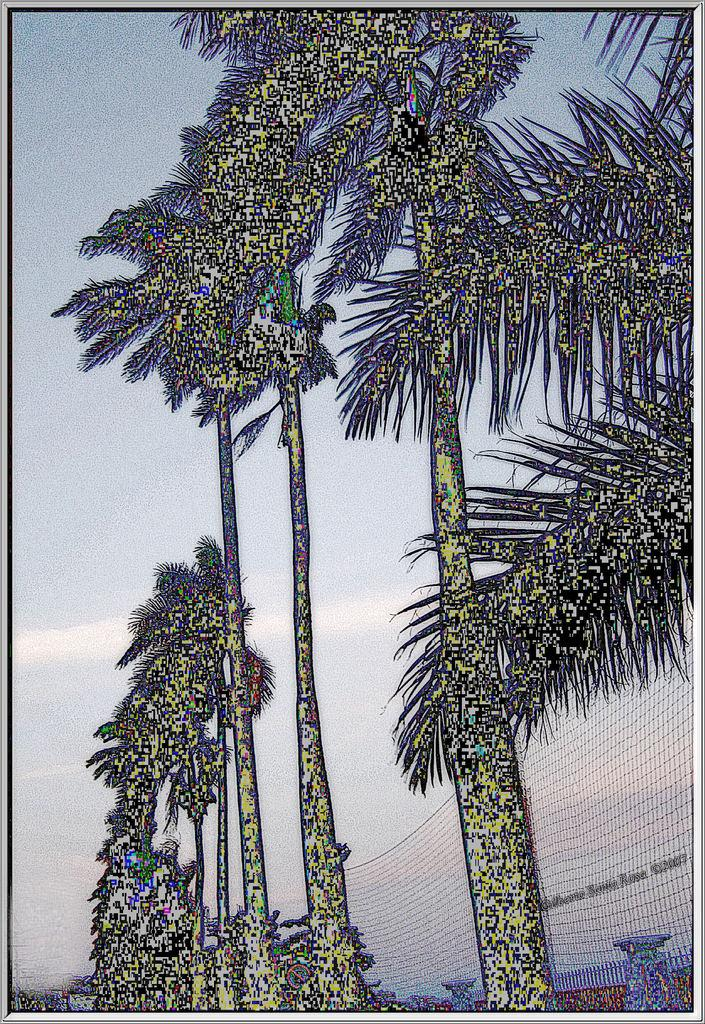What can be inferred about the image based on the provided facts? The image is edited, and it features trees, a fence, a visible sky with clouds, and borders. Can you describe the natural elements in the image? The image contains trees and a sky with clouds. What type of man-made structure is present in the image? There is a fence in the image. How is the image framed or contained? The image has borders. What type of plate is being used to serve the food in the image? There is no food or plate present in the image; it features trees, a fence, and a sky with clouds. How does the bat interact with the trees in the image? There is no bat present in the image; it only contains trees, a fence, and a sky with clouds. 